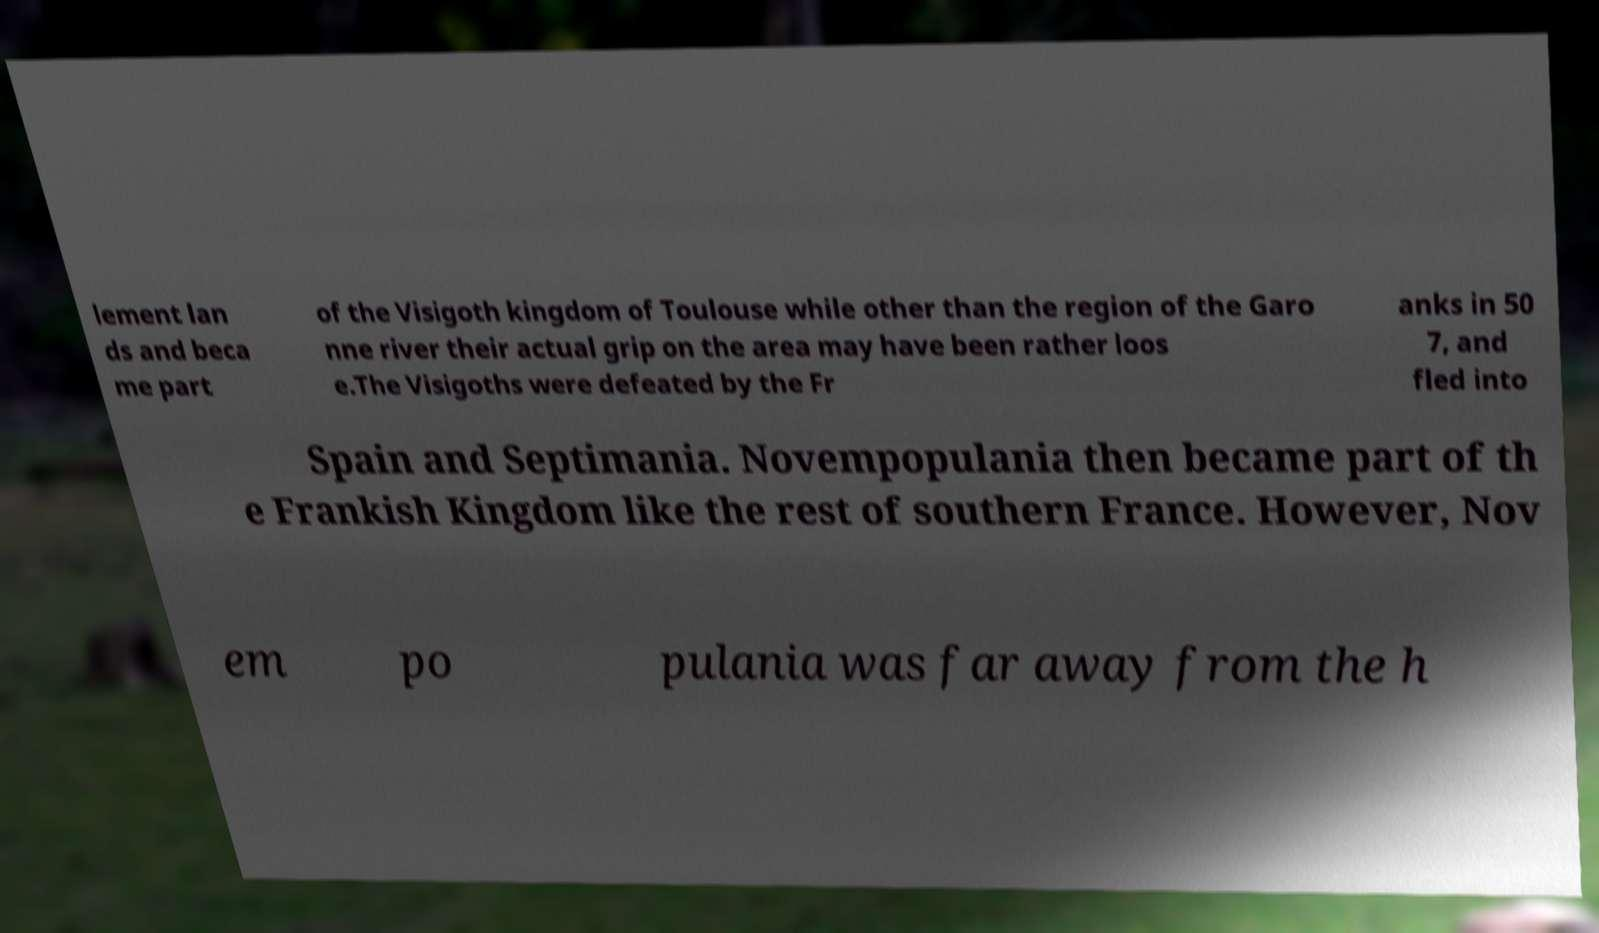I need the written content from this picture converted into text. Can you do that? lement lan ds and beca me part of the Visigoth kingdom of Toulouse while other than the region of the Garo nne river their actual grip on the area may have been rather loos e.The Visigoths were defeated by the Fr anks in 50 7, and fled into Spain and Septimania. Novempopulania then became part of th e Frankish Kingdom like the rest of southern France. However, Nov em po pulania was far away from the h 